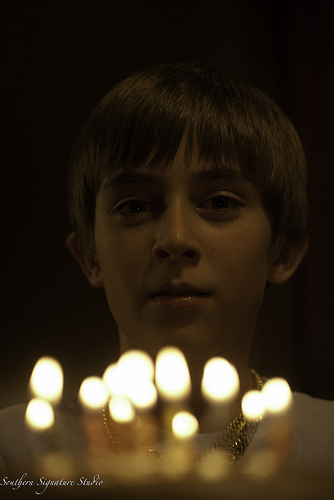<image>
Is there a boy on the candles? No. The boy is not positioned on the candles. They may be near each other, but the boy is not supported by or resting on top of the candles. 